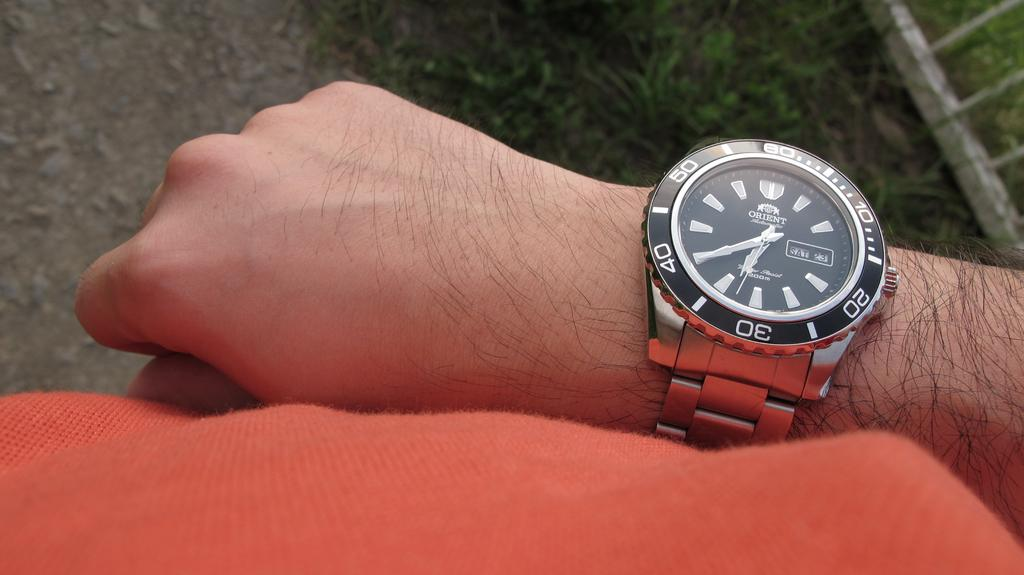<image>
Render a clear and concise summary of the photo. An Orient brand watch is on someone's arm who is wearing red. 